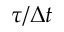<formula> <loc_0><loc_0><loc_500><loc_500>\tau / \Delta t</formula> 